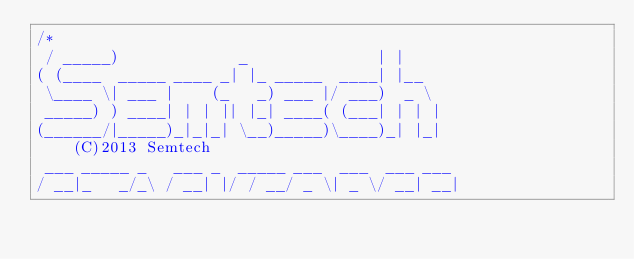<code> <loc_0><loc_0><loc_500><loc_500><_C_>/*
 / _____)             _              | |
( (____  _____ ____ _| |_ _____  ____| |__
 \____ \| ___ |    (_   _) ___ |/ ___)  _ \
 _____) ) ____| | | || |_| ____( (___| | | |
(______/|_____)_|_|_| \__)_____)\____)_| |_|
    (C)2013 Semtech
 ___ _____ _   ___ _  _____ ___  ___  ___ ___
/ __|_   _/_\ / __| |/ / __/ _ \| _ \/ __| __|</code> 